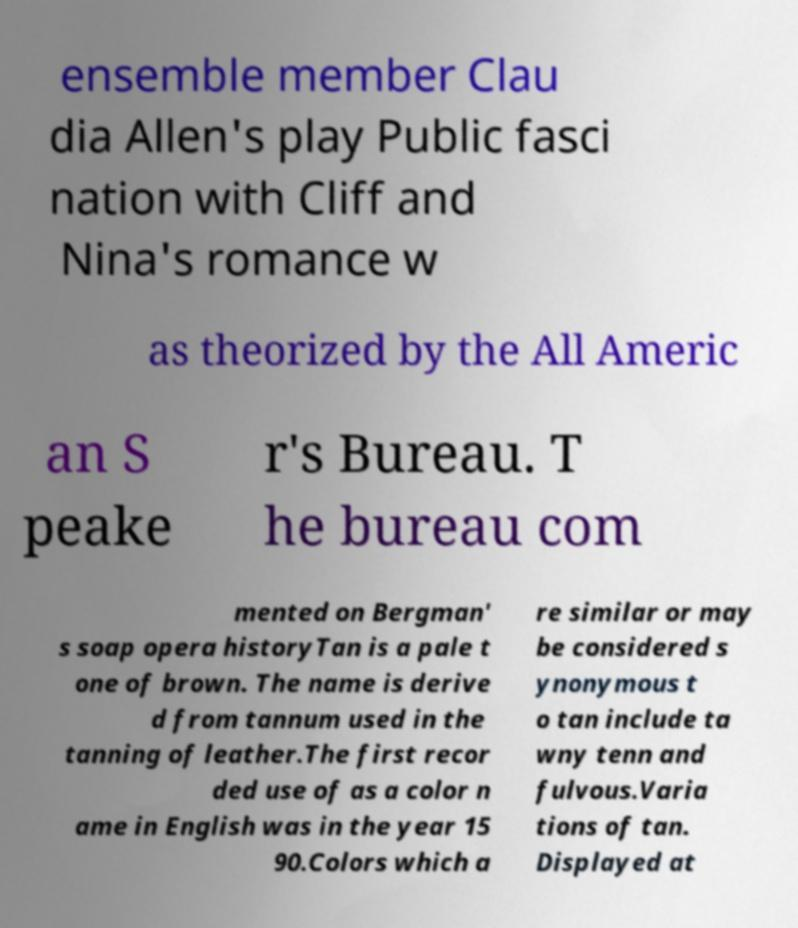Can you accurately transcribe the text from the provided image for me? ensemble member Clau dia Allen's play Public fasci nation with Cliff and Nina's romance w as theorized by the All Americ an S peake r's Bureau. T he bureau com mented on Bergman' s soap opera historyTan is a pale t one of brown. The name is derive d from tannum used in the tanning of leather.The first recor ded use of as a color n ame in English was in the year 15 90.Colors which a re similar or may be considered s ynonymous t o tan include ta wny tenn and fulvous.Varia tions of tan. Displayed at 